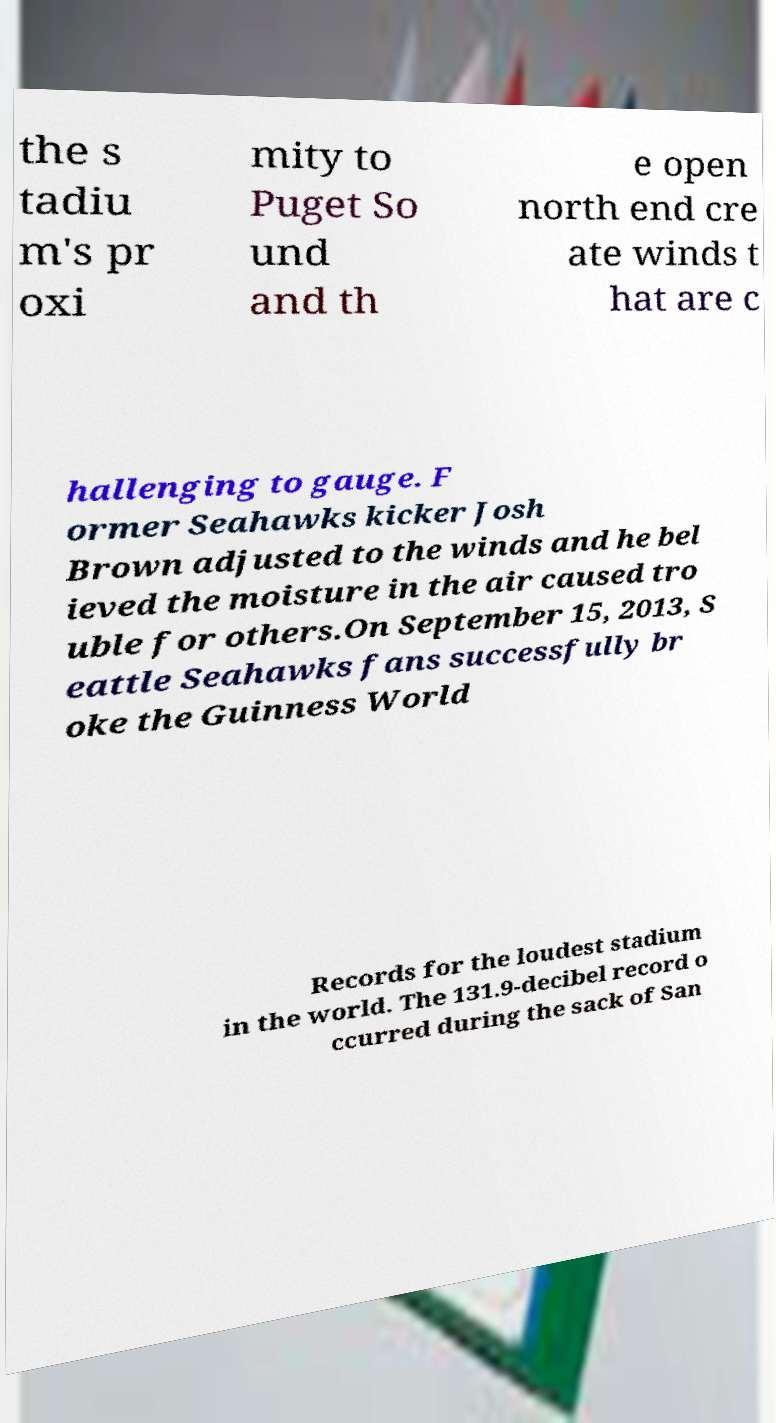For documentation purposes, I need the text within this image transcribed. Could you provide that? the s tadiu m's pr oxi mity to Puget So und and th e open north end cre ate winds t hat are c hallenging to gauge. F ormer Seahawks kicker Josh Brown adjusted to the winds and he bel ieved the moisture in the air caused tro uble for others.On September 15, 2013, S eattle Seahawks fans successfully br oke the Guinness World Records for the loudest stadium in the world. The 131.9-decibel record o ccurred during the sack of San 